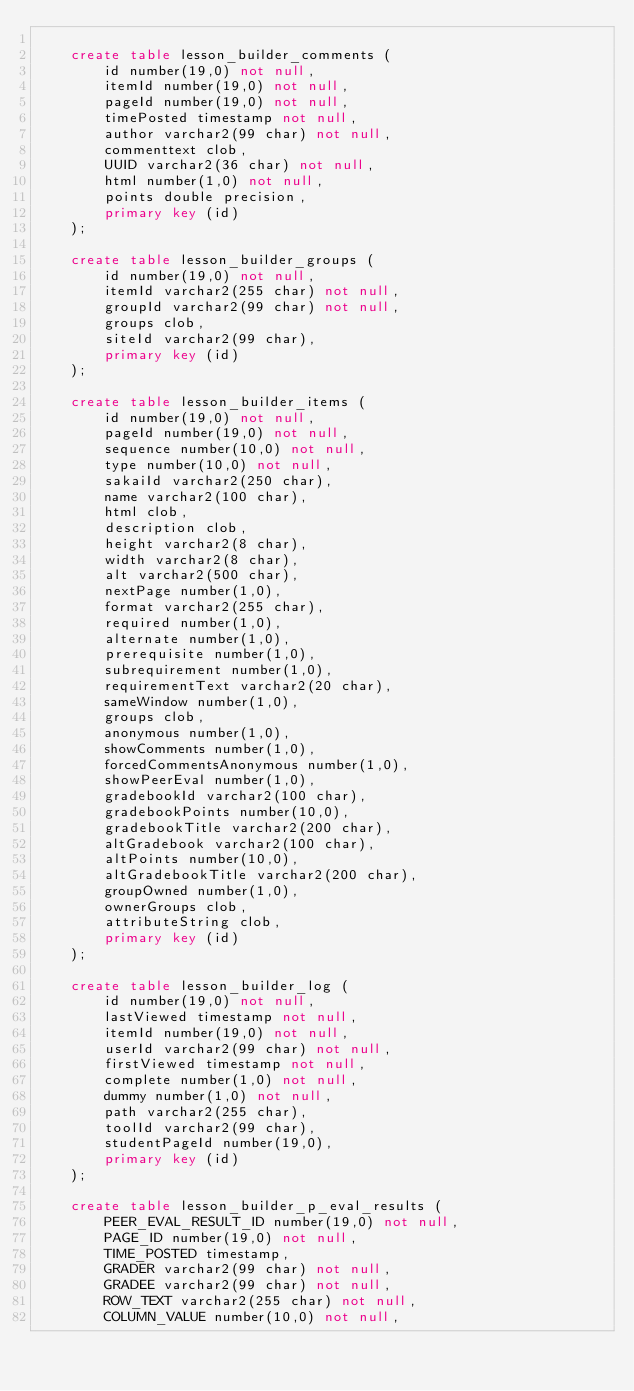<code> <loc_0><loc_0><loc_500><loc_500><_SQL_>
    create table lesson_builder_comments (
        id number(19,0) not null,
        itemId number(19,0) not null,
        pageId number(19,0) not null,
        timePosted timestamp not null,
        author varchar2(99 char) not null,
        commenttext clob,
        UUID varchar2(36 char) not null,
        html number(1,0) not null,
        points double precision,
        primary key (id)
    );

    create table lesson_builder_groups (
        id number(19,0) not null,
        itemId varchar2(255 char) not null,
        groupId varchar2(99 char) not null,
        groups clob,
        siteId varchar2(99 char),
        primary key (id)
    );

    create table lesson_builder_items (
        id number(19,0) not null,
        pageId number(19,0) not null,
        sequence number(10,0) not null,
        type number(10,0) not null,
        sakaiId varchar2(250 char),
        name varchar2(100 char),
        html clob,
        description clob,
        height varchar2(8 char),
        width varchar2(8 char),
        alt varchar2(500 char),
        nextPage number(1,0),
        format varchar2(255 char),
        required number(1,0),
        alternate number(1,0),
        prerequisite number(1,0),
        subrequirement number(1,0),
        requirementText varchar2(20 char),
        sameWindow number(1,0),
        groups clob,
        anonymous number(1,0),
        showComments number(1,0),
        forcedCommentsAnonymous number(1,0),
        showPeerEval number(1,0),
        gradebookId varchar2(100 char),
        gradebookPoints number(10,0),
        gradebookTitle varchar2(200 char),
        altGradebook varchar2(100 char),
        altPoints number(10,0),
        altGradebookTitle varchar2(200 char),
        groupOwned number(1,0),
        ownerGroups clob,
        attributeString clob,
        primary key (id)
    );

    create table lesson_builder_log (
        id number(19,0) not null,
        lastViewed timestamp not null,
        itemId number(19,0) not null,
        userId varchar2(99 char) not null,
        firstViewed timestamp not null,
        complete number(1,0) not null,
        dummy number(1,0) not null,
        path varchar2(255 char),
        toolId varchar2(99 char),
        studentPageId number(19,0),
        primary key (id)
    );

    create table lesson_builder_p_eval_results (
        PEER_EVAL_RESULT_ID number(19,0) not null,
        PAGE_ID number(19,0) not null,
        TIME_POSTED timestamp,
        GRADER varchar2(99 char) not null,
        GRADEE varchar2(99 char) not null,
        ROW_TEXT varchar2(255 char) not null,
        COLUMN_VALUE number(10,0) not null,</code> 